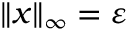<formula> <loc_0><loc_0><loc_500><loc_500>\| { \boldsymbol x } \| _ { \infty } = \varepsilon</formula> 